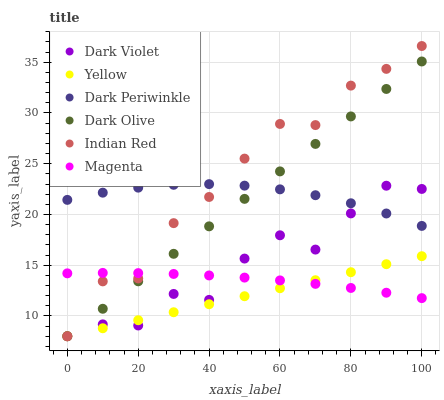Does Yellow have the minimum area under the curve?
Answer yes or no. Yes. Does Indian Red have the maximum area under the curve?
Answer yes or no. Yes. Does Dark Violet have the minimum area under the curve?
Answer yes or no. No. Does Dark Violet have the maximum area under the curve?
Answer yes or no. No. Is Yellow the smoothest?
Answer yes or no. Yes. Is Dark Violet the roughest?
Answer yes or no. Yes. Is Dark Violet the smoothest?
Answer yes or no. No. Is Yellow the roughest?
Answer yes or no. No. Does Dark Olive have the lowest value?
Answer yes or no. Yes. Does Magenta have the lowest value?
Answer yes or no. No. Does Indian Red have the highest value?
Answer yes or no. Yes. Does Yellow have the highest value?
Answer yes or no. No. Is Yellow less than Dark Periwinkle?
Answer yes or no. Yes. Is Dark Periwinkle greater than Yellow?
Answer yes or no. Yes. Does Dark Olive intersect Dark Periwinkle?
Answer yes or no. Yes. Is Dark Olive less than Dark Periwinkle?
Answer yes or no. No. Is Dark Olive greater than Dark Periwinkle?
Answer yes or no. No. Does Yellow intersect Dark Periwinkle?
Answer yes or no. No. 